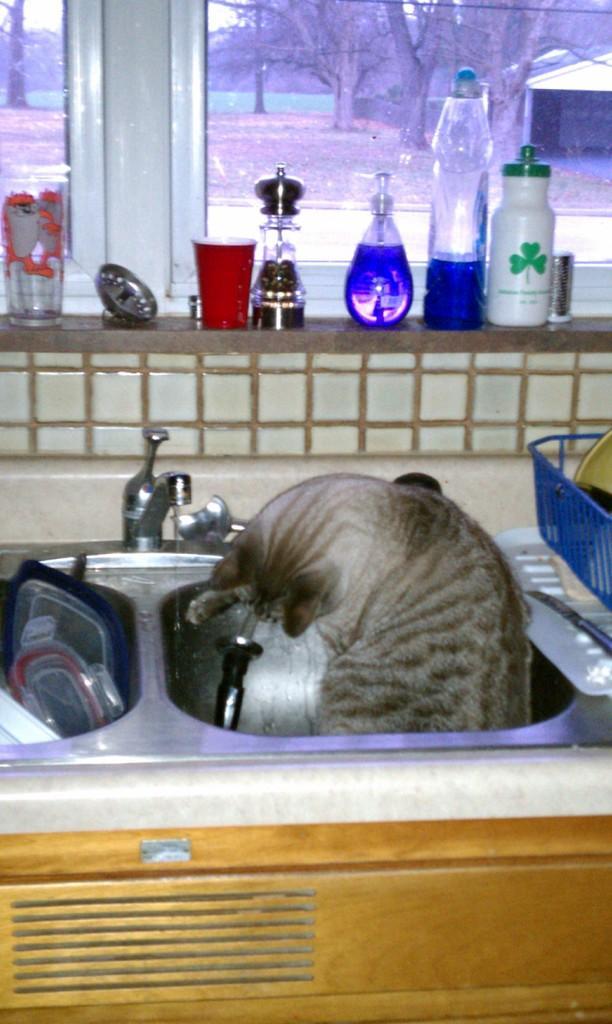In one or two sentences, can you explain what this image depicts? In this image we can see a cat in the sink. There are bottles and window glasses through which we can see trees. 